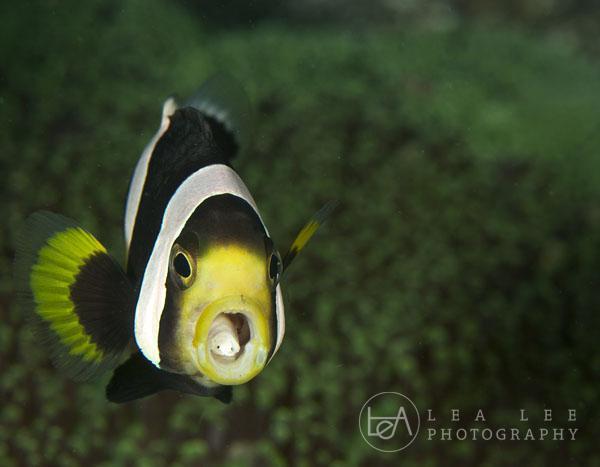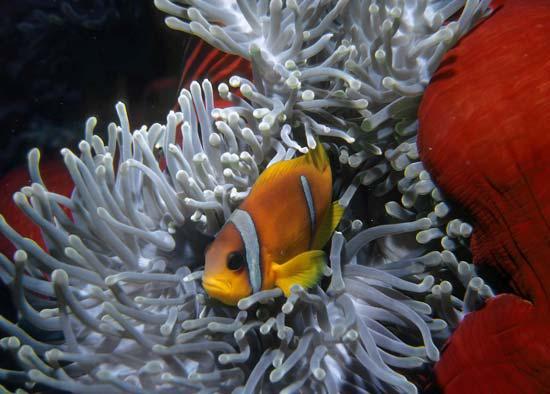The first image is the image on the left, the second image is the image on the right. Evaluate the accuracy of this statement regarding the images: "Several fish swim around the anemone in the image on the left, while a single fish swims in the image on the right.". Is it true? Answer yes or no. No. The first image is the image on the left, the second image is the image on the right. Evaluate the accuracy of this statement regarding the images: "The left and right image contains the same number of fish.". Is it true? Answer yes or no. Yes. 